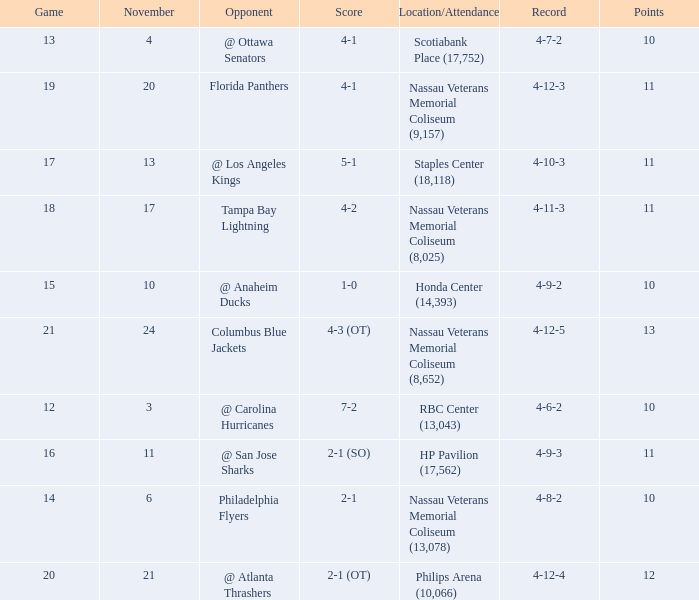What is the least amount of points? 10.0. 